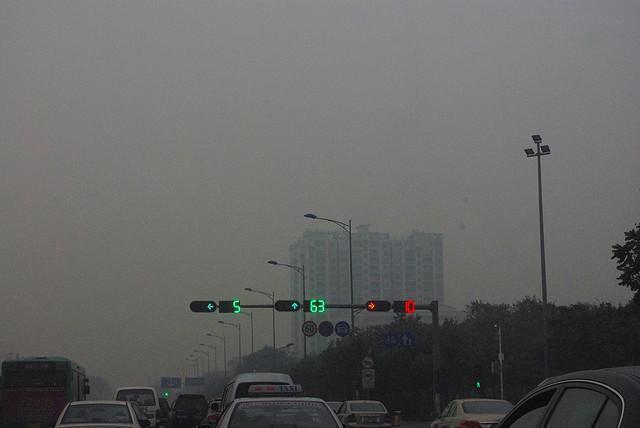How many windshields do you see?
Give a very brief answer. 0. How many Volkswagens are visible?
Give a very brief answer. 0. How many white cars are on the road?
Give a very brief answer. 5. How many traffic light on lite up?
Give a very brief answer. 3. How many street lights are visible?
Give a very brief answer. 3. How many traffic lights are green in the picture?
Give a very brief answer. 2. How many bikes are on the road?
Give a very brief answer. 0. How many cars can you see?
Give a very brief answer. 2. 